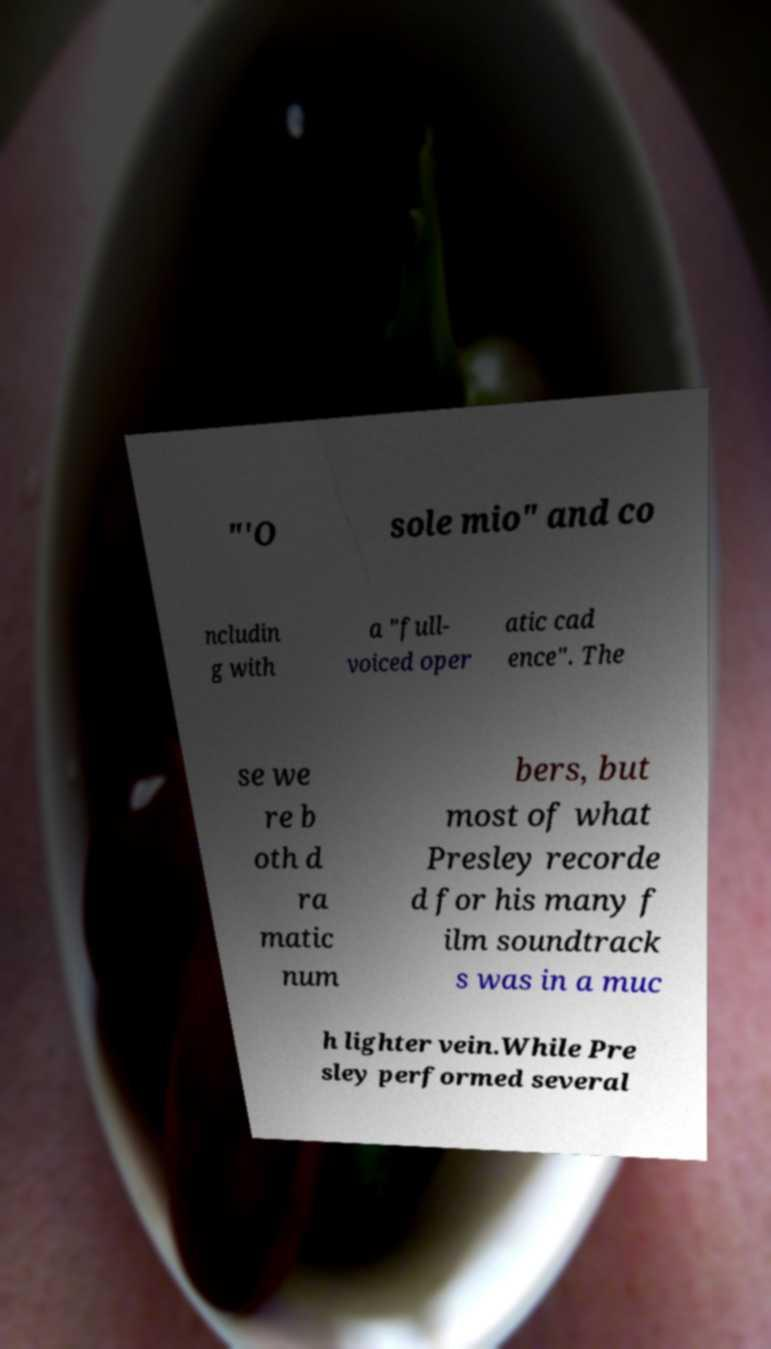Can you accurately transcribe the text from the provided image for me? "'O sole mio" and co ncludin g with a "full- voiced oper atic cad ence". The se we re b oth d ra matic num bers, but most of what Presley recorde d for his many f ilm soundtrack s was in a muc h lighter vein.While Pre sley performed several 